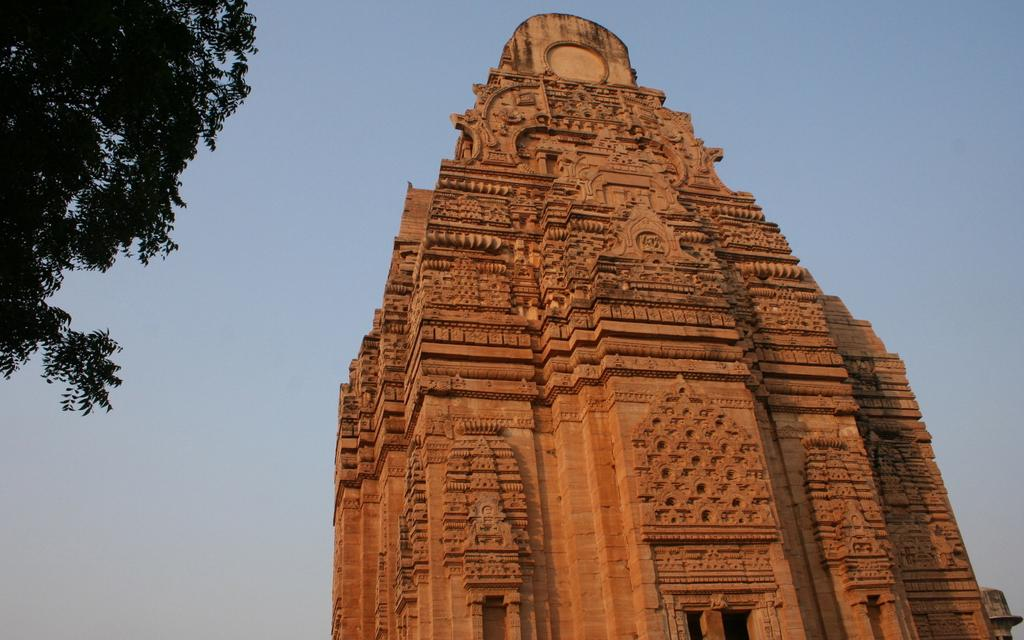What structure is located on the right side of the image? There is a monument on the right side of the image. What type of vegetation is on the left side of the image? There is a tree on the left side of the image. What is visible at the top of the image? The sky is visible at the top of the image. Can you see any mittens hanging from the tree in the image? There are no mittens present in the image; it features a monument and a tree. What type of music is being played near the monument in the image? There is no music or indication of any sound in the image; it only shows a monument and a tree. 